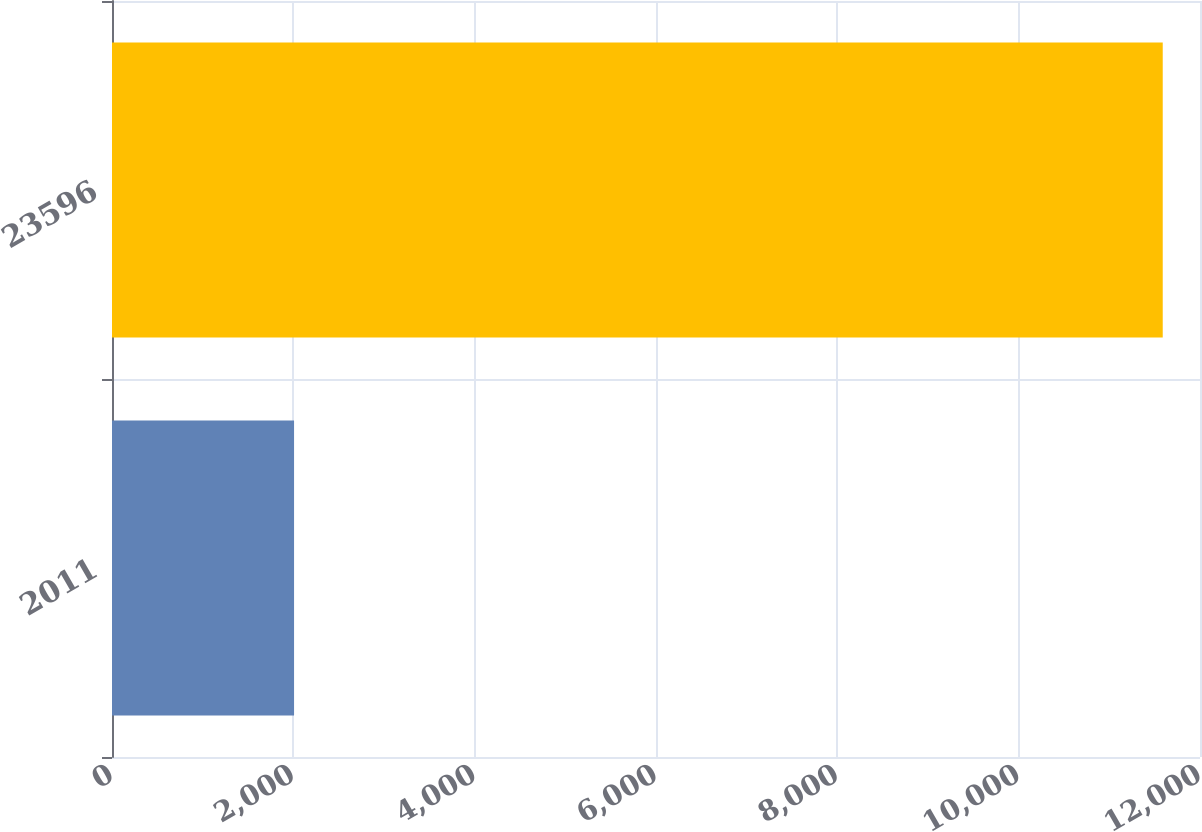<chart> <loc_0><loc_0><loc_500><loc_500><bar_chart><fcel>2011<fcel>23596<nl><fcel>2008<fcel>11589<nl></chart> 